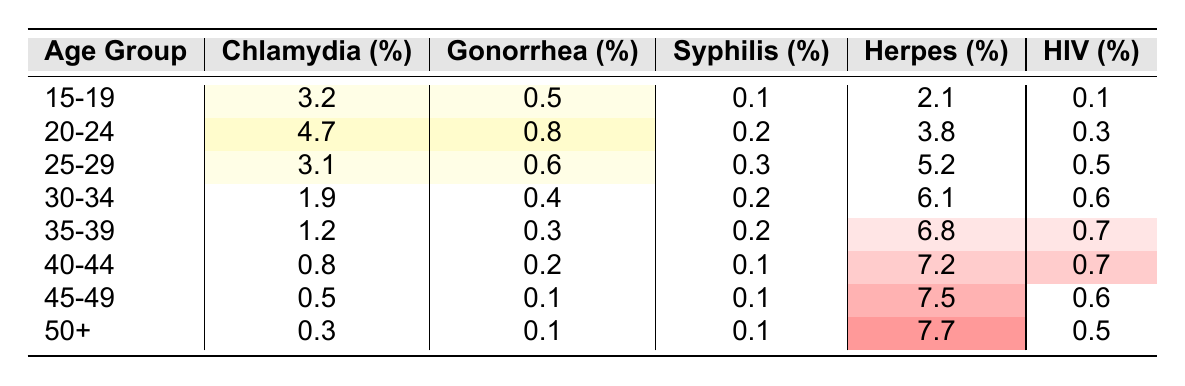What is the percentage of Chlamydia in the 15-19 age group? In the table, under the "Chlamydia (%)" column for the "15-19" age group, the value is 3.2%.
Answer: 3.2% Which age group has the highest percentage of Herpes? By reviewing the "Herpes (%)" column, the "50+" age group has the highest percentage at 7.7%.
Answer: 50+ What is the percentage difference of Gonorrhea between the age groups 20-24 and 35-39? The Gonorrhea percentage for age group 20-24 is 0.8% and for 35-39 is 0.3%. The difference is 0.8% - 0.3% = 0.5%.
Answer: 0.5% Is the percentage of Syphilis higher in the 30-34 age group compared to the 40-44 age group? The percentage of Syphilis in the 30-34 age group is 0.2% and in the 40-44 age group is 0.1%. Therefore, 0.2% > 0.1%, which makes the statement true.
Answer: Yes What is the average percentage of HIV among all age groups listed? To find the average, we sum the HIV percentages: 0.1 + 0.3 + 0.5 + 0.6 + 0.7 + 0.7 + 0.6 + 0.5 = 3.4%. Then divide by the number of age groups (8): 3.4% / 8 = 0.425%.
Answer: 0.425% Which age group has both Herpes and HIV percentages above 5%? Reviewing the table, only the "30-34" age group has Herpes at 6.1% (which is above 5%), but its HIV percentage is 0.6% (not above 5%). Therefore, no age group meets both criteria.
Answer: No age group meets both criteria What is the trend in Chlamydia percentage from the age group 15-19 to 50+? Looking at the Chlamydia percentages, they go from 3.2% in 15-19 to 0.3% in 50+. Therefore, there is a decreasing trend in Chlamydia percentages as age increases.
Answer: Decreasing trend What is the total percentage of all STIs for the 25-29 age group? To calculate the total, we add all the STI percentages for the 25-29 age group: Chlamydia (3.1%) + Gonorrhea (0.6%) + Syphilis (0.3%) + Herpes (5.2%) + HIV (0.5%) = 9.7%.
Answer: 9.7% 